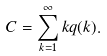<formula> <loc_0><loc_0><loc_500><loc_500>C = \sum _ { k = 1 } ^ { \infty } k q ( k ) .</formula> 